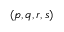<formula> <loc_0><loc_0><loc_500><loc_500>( p , q , r , s )</formula> 